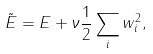Convert formula to latex. <formula><loc_0><loc_0><loc_500><loc_500>\tilde { E } = E + \nu \frac { 1 } { 2 } \sum _ { i } w _ { i } ^ { 2 } ,</formula> 